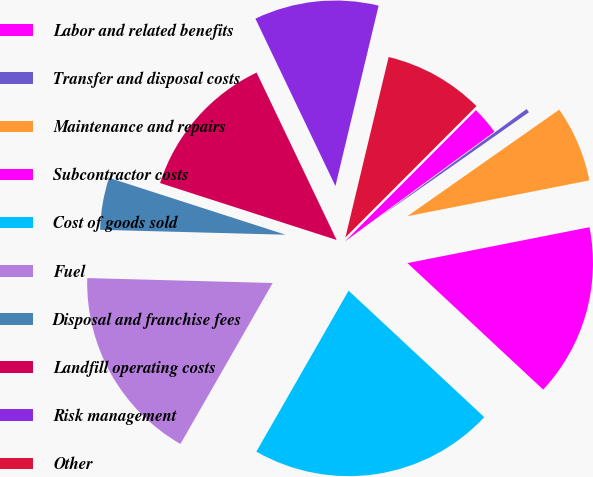Convert chart to OTSL. <chart><loc_0><loc_0><loc_500><loc_500><pie_chart><fcel>Labor and related benefits<fcel>Transfer and disposal costs<fcel>Maintenance and repairs<fcel>Subcontractor costs<fcel>Cost of goods sold<fcel>Fuel<fcel>Disposal and franchise fees<fcel>Landfill operating costs<fcel>Risk management<fcel>Other<nl><fcel>2.44%<fcel>0.34%<fcel>6.64%<fcel>15.04%<fcel>21.34%<fcel>17.14%<fcel>4.54%<fcel>12.94%<fcel>10.84%<fcel>8.74%<nl></chart> 